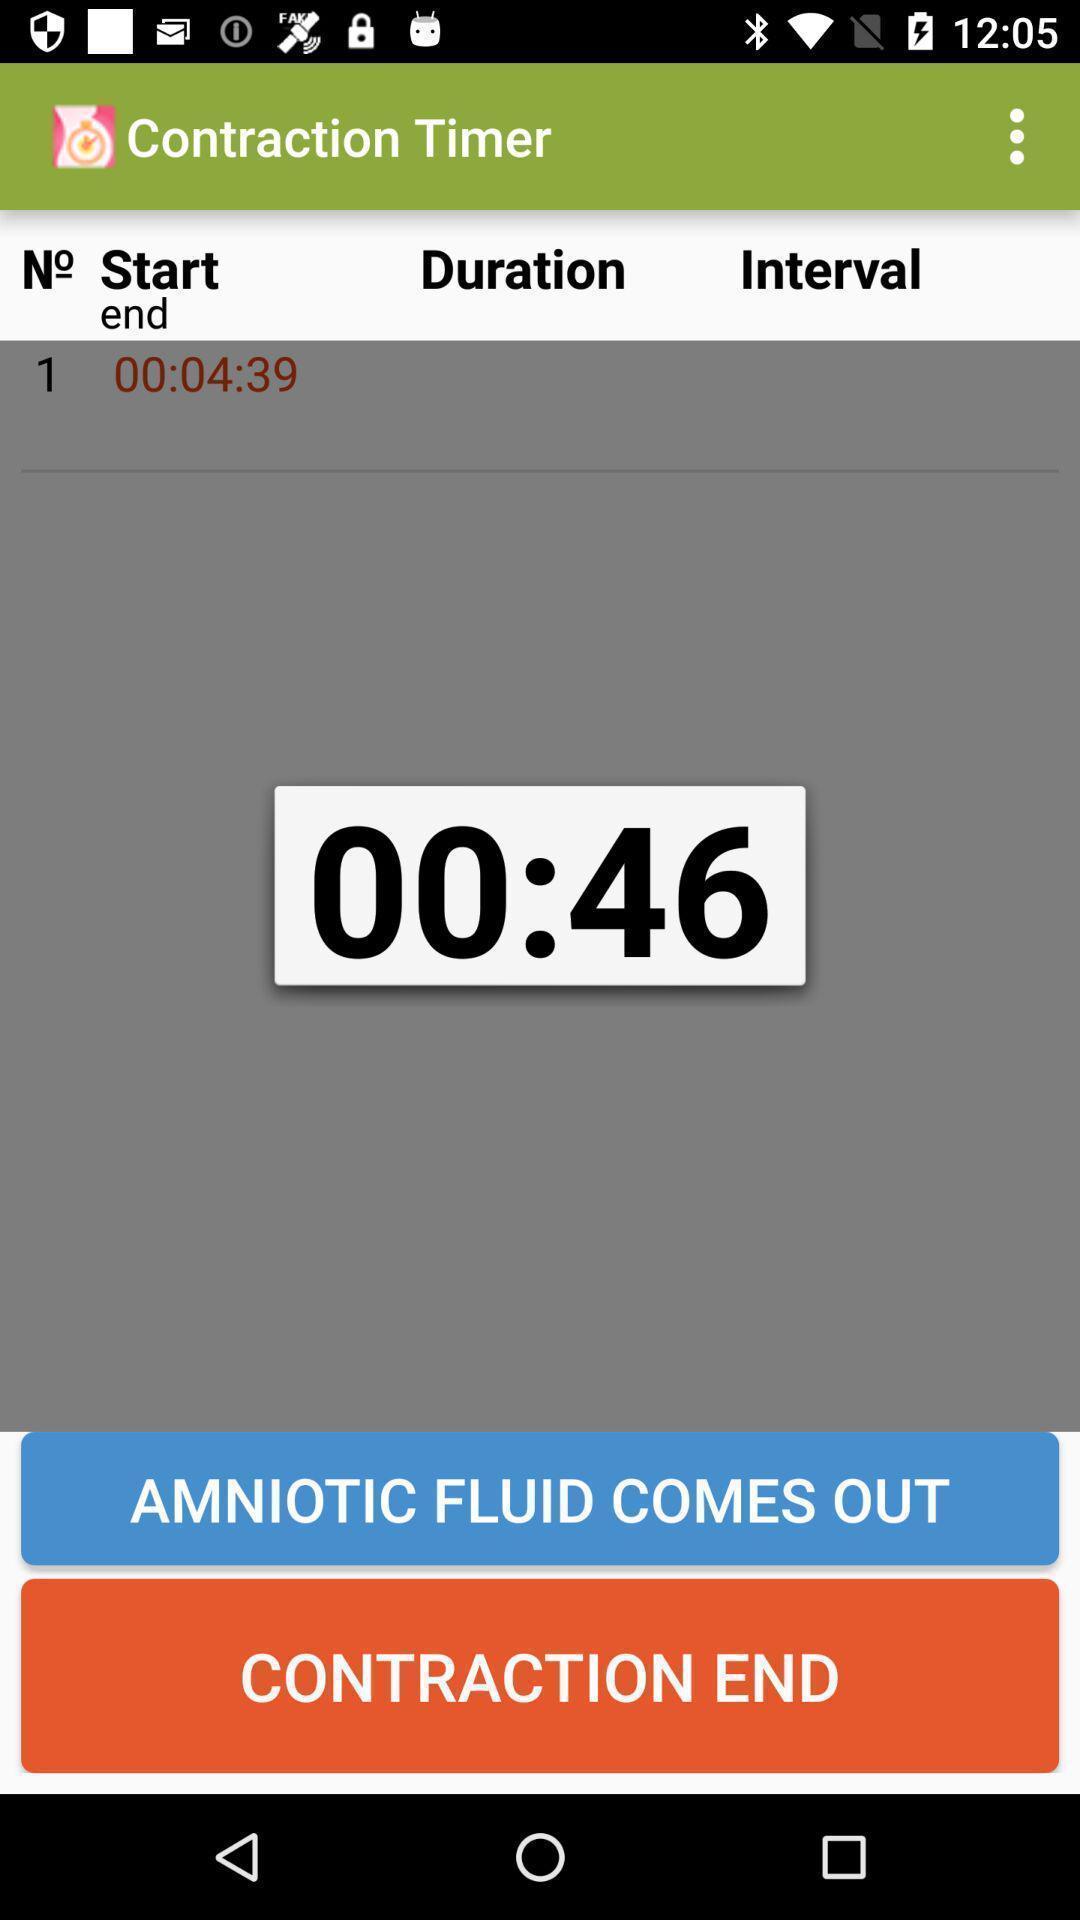Give me a summary of this screen capture. Timer page. 